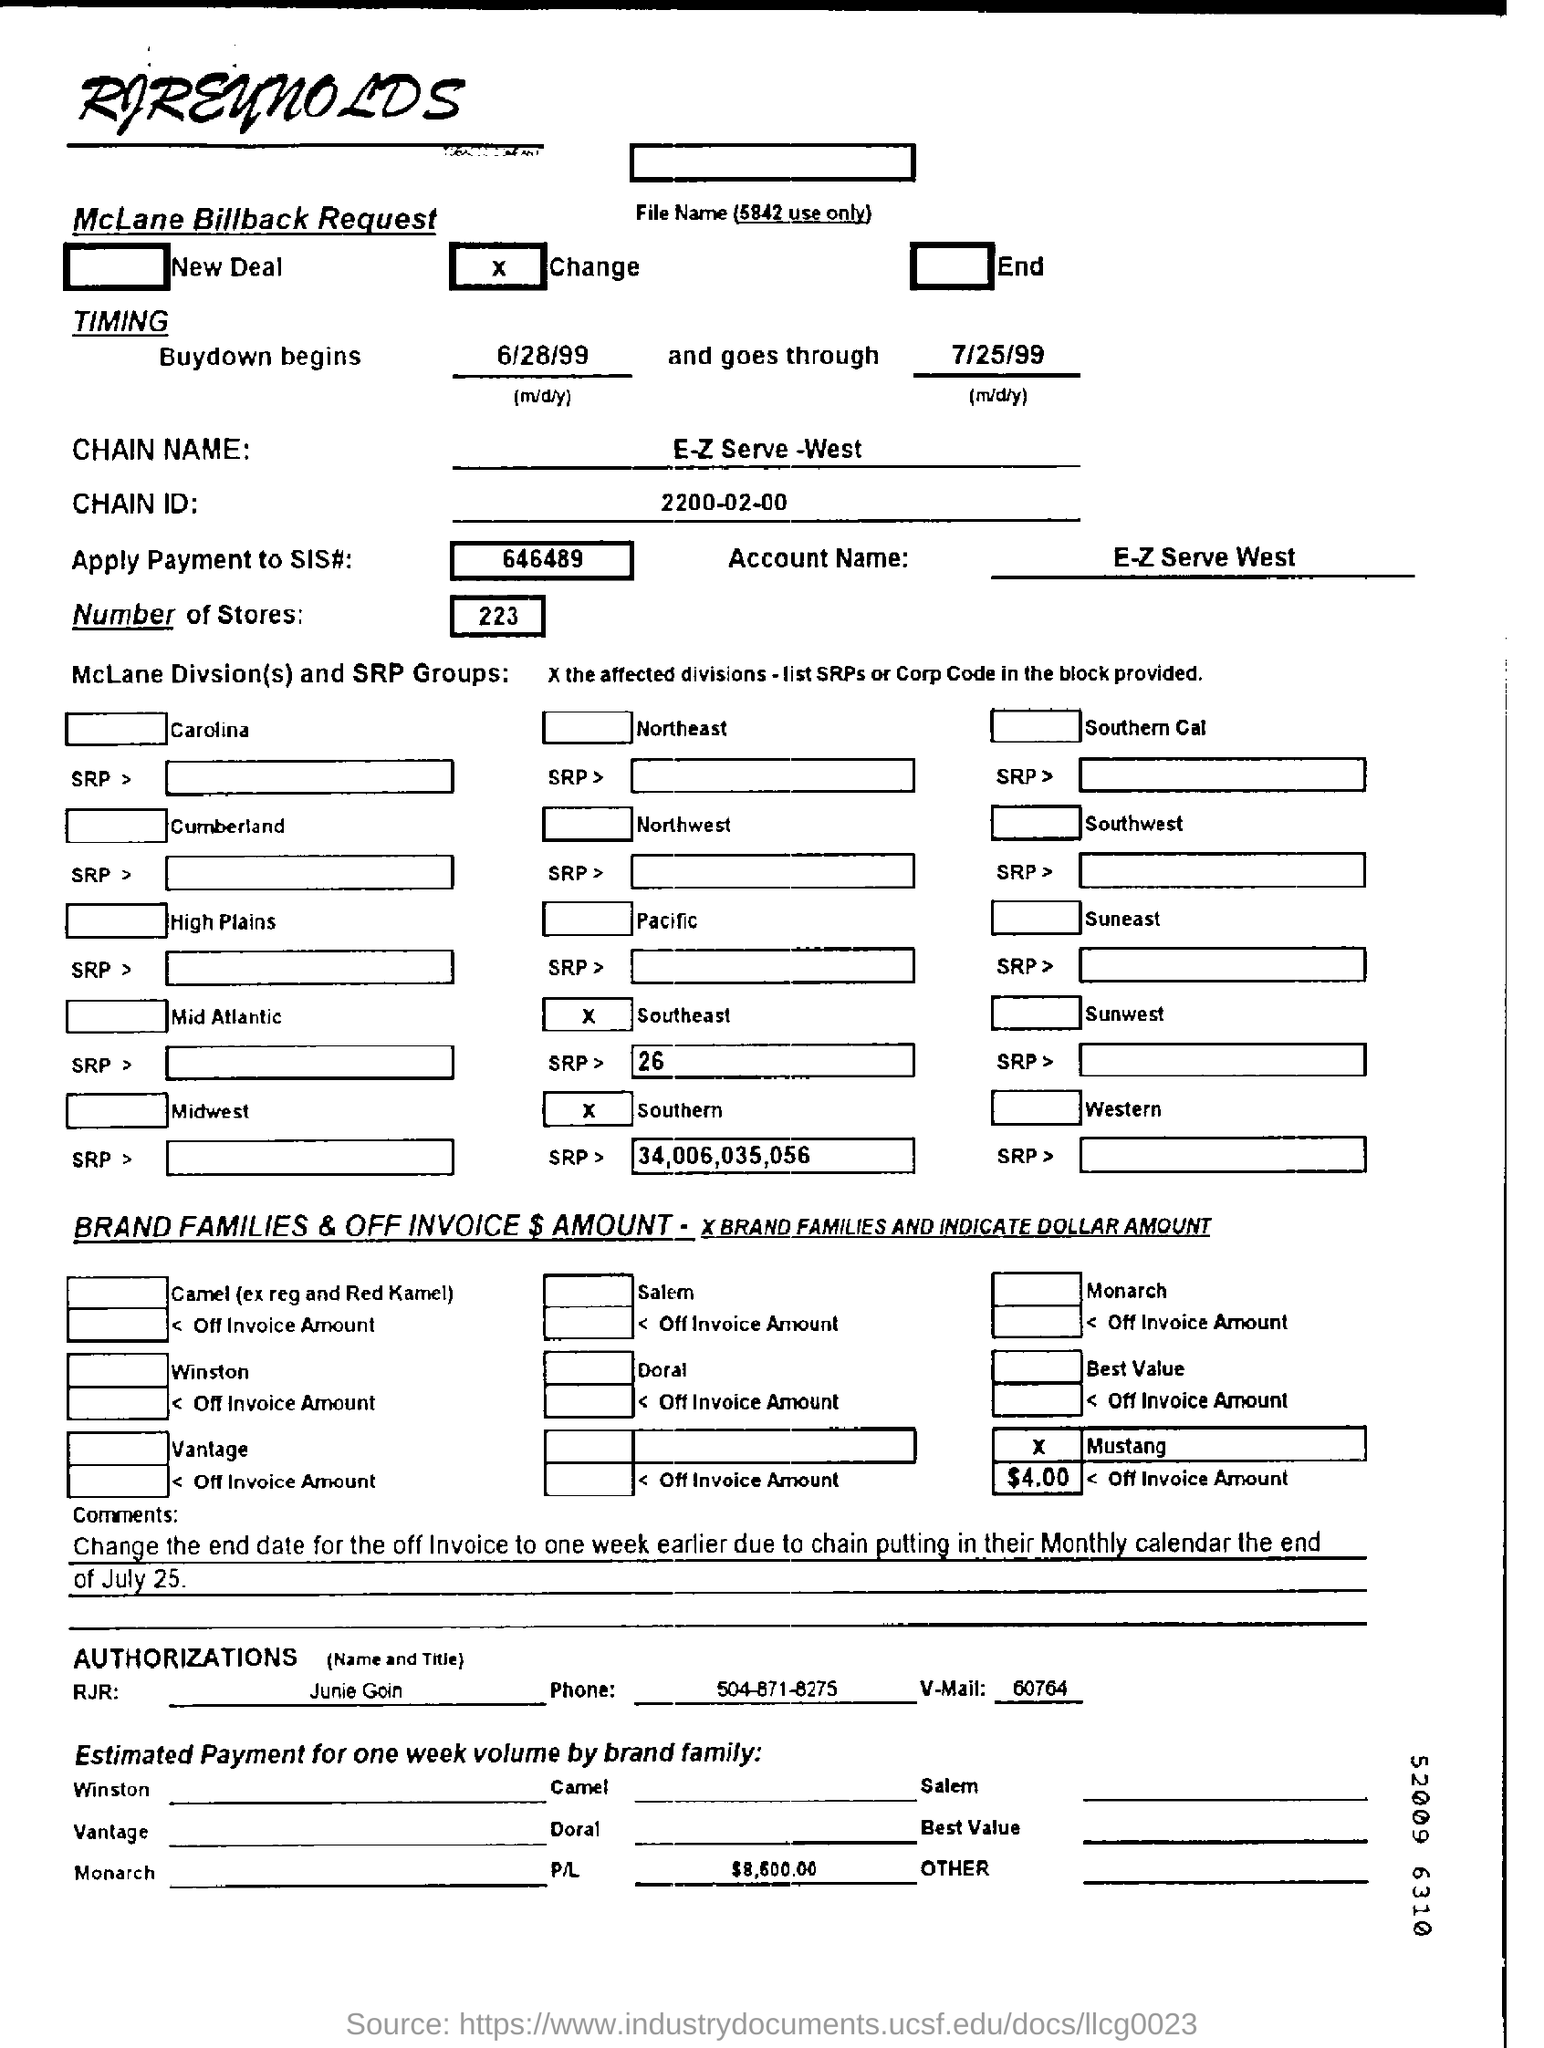List a handful of essential elements in this visual. There are 223 stores in total. The account name is "E-Z Serve West. The RJR mentioned is Junie Goin. 